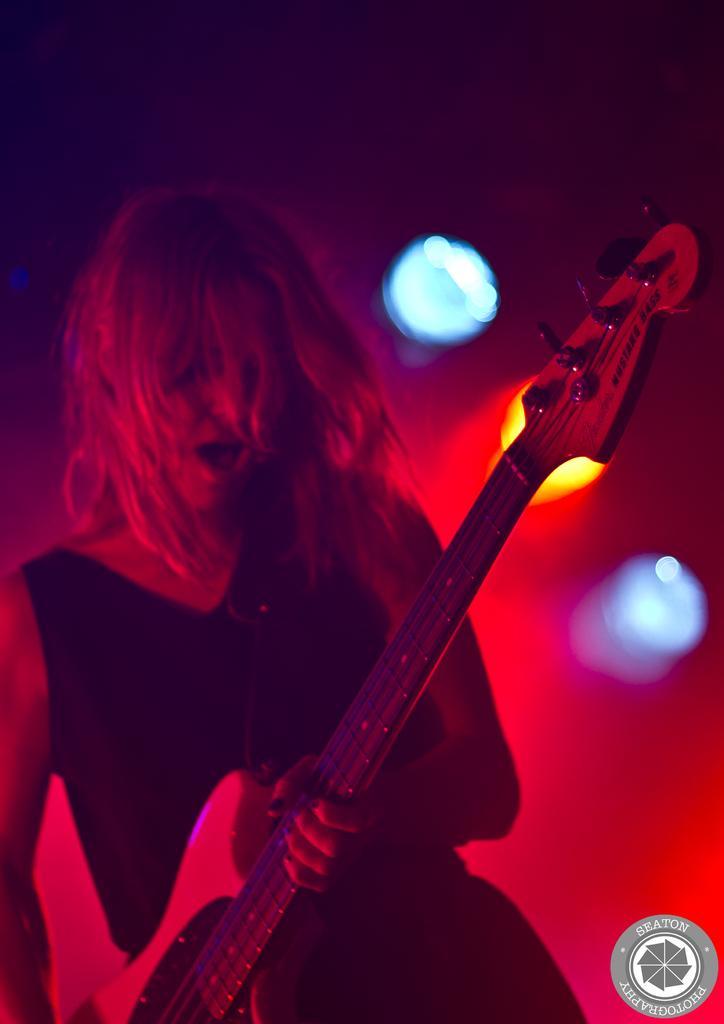Please provide a concise description of this image. In this image I can see the person holding the guitar. I can see the person wearing the black color dress. In the background there are lights which are in orange and blue color. 